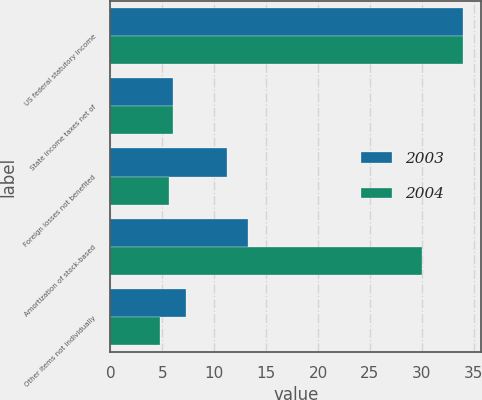<chart> <loc_0><loc_0><loc_500><loc_500><stacked_bar_chart><ecel><fcel>US federal statutory income<fcel>State income taxes net of<fcel>Foreign losses not benefited<fcel>Amortization of stock-based<fcel>Other items not individually<nl><fcel>2003<fcel>34<fcel>6<fcel>11.24<fcel>13.27<fcel>7.27<nl><fcel>2004<fcel>34<fcel>6<fcel>5.64<fcel>30<fcel>4.78<nl></chart> 